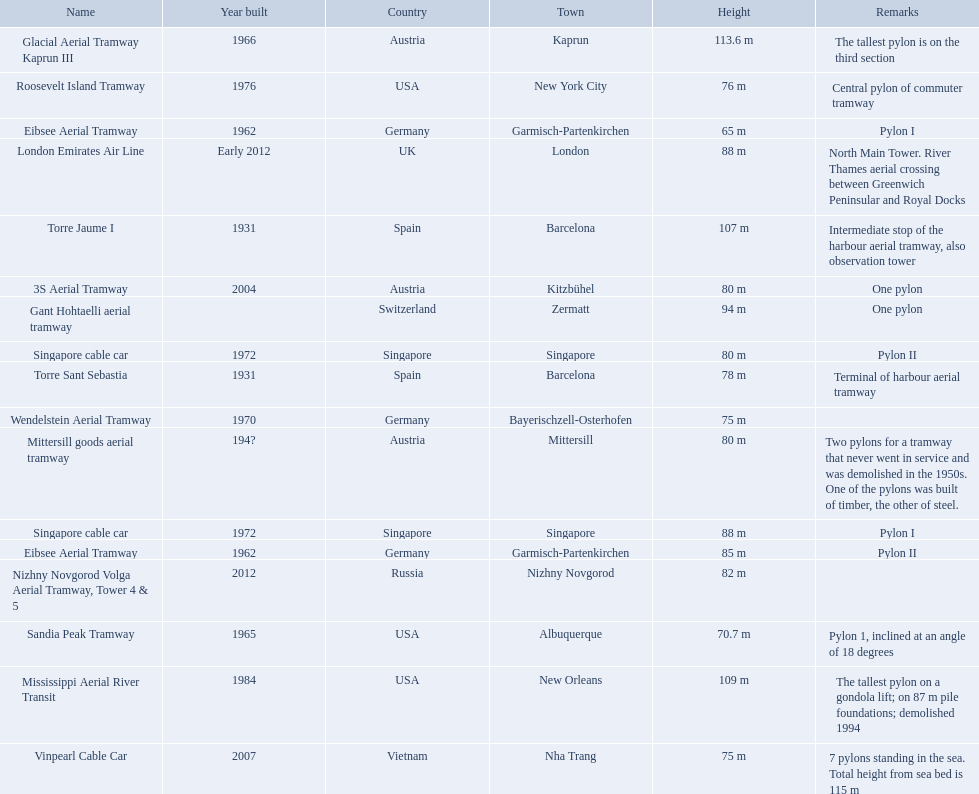How many aerial lift pylon's on the list are located in the usa? Mississippi Aerial River Transit, Roosevelt Island Tramway, Sandia Peak Tramway. Of the pylon's located in the usa how many were built after 1970? Mississippi Aerial River Transit, Roosevelt Island Tramway. Of the pylon's built after 1970 which is the tallest pylon on a gondola lift? Mississippi Aerial River Transit. How many meters is the tallest pylon on a gondola lift? 109 m. 